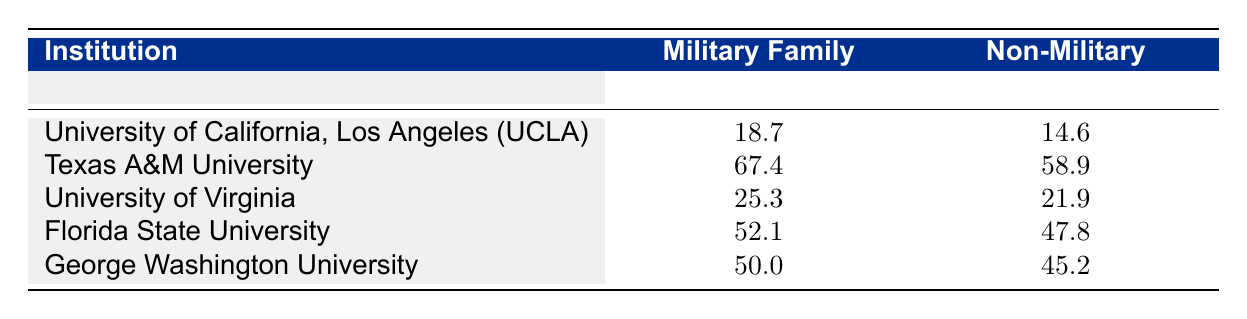What is the acceptance rate for military family students at Texas A&M University? According to the table, the acceptance rate for military family students at Texas A&M University is listed directly in the row for that institution. It shows a rate of 67.4%.
Answer: 67.4 What is the difference in acceptance rates between military family students and non-military students at the University of California, Los Angeles? For UCLA, the acceptance rate for military family students is 18.7%, while for non-military students it is 14.6%. To find the difference, subtract the non-military rate from the military family rate: 18.7 - 14.6 = 4.1.
Answer: 4.1 Is the acceptance rate for military family students higher than that for non-military students at Florida State University? The table shows acceptance rates of 52.1% for military family students and 47.8% for non-military students at Florida State University, indicating that the military family rate is higher.
Answer: Yes What is the average acceptance rate for non-military students across all listed institutions? To find the average acceptance rate for non-military students, we sum the rates: 14.6 + 58.9 + 21.9 + 47.8 + 45.2 = 188.4, then divide by the number of institutions (5): 188.4 / 5 = 37.68.
Answer: 37.68 Which university has the highest acceptance rate for military family students? By examining the table, Texas A&M University has the highest acceptance rate for military family students at 67.4%.
Answer: Texas A&M University 